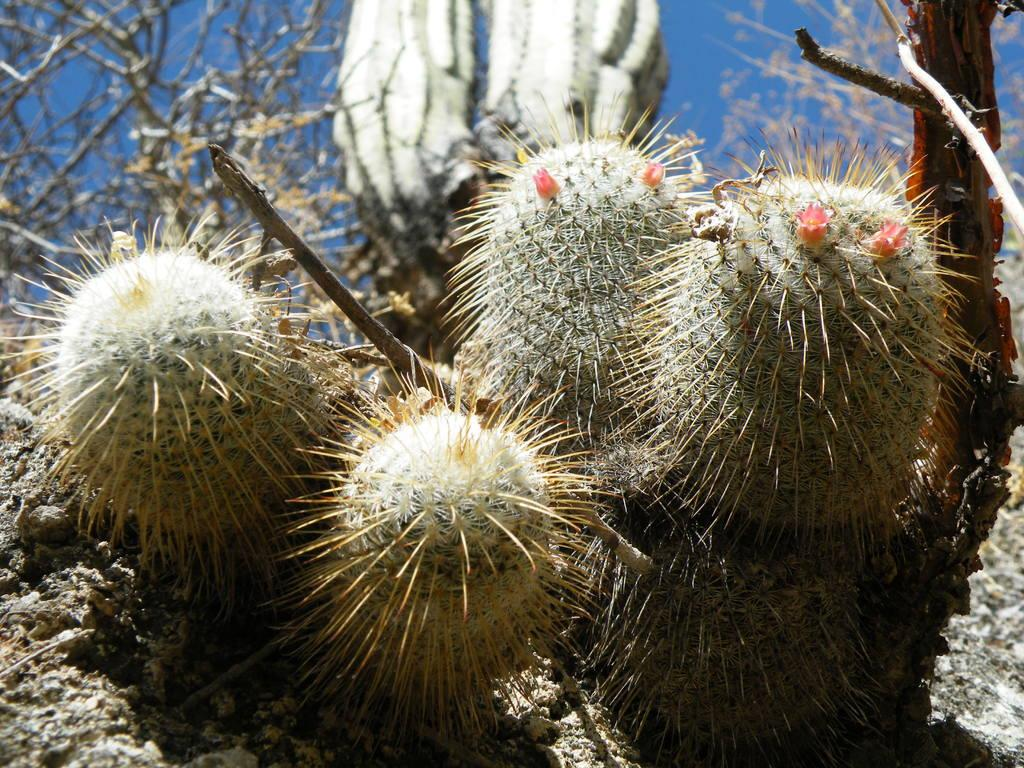What is depicted on the ground in the image? There are planets depicted on the ground in the image. What can be seen in the background of the image? The sky is visible in the background of the image. What direction is the noise coming from in the image? There is no noise present in the image, as it only features planets on the ground and the sky in the background. 